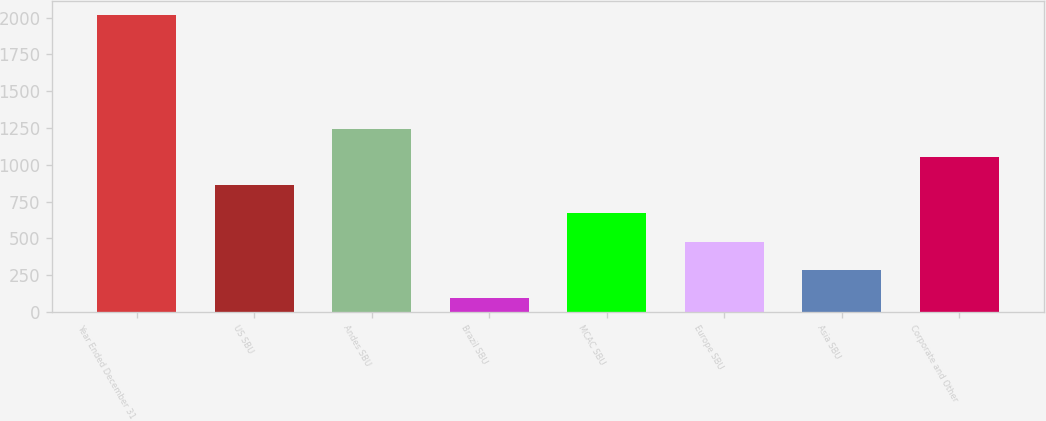Convert chart to OTSL. <chart><loc_0><loc_0><loc_500><loc_500><bar_chart><fcel>Year Ended December 31<fcel>US SBU<fcel>Andes SBU<fcel>Brazil SBU<fcel>MCAC SBU<fcel>Europe SBU<fcel>Asia SBU<fcel>Corporate and Other<nl><fcel>2015<fcel>861.8<fcel>1246.2<fcel>93<fcel>669.6<fcel>477.4<fcel>285.2<fcel>1054<nl></chart> 